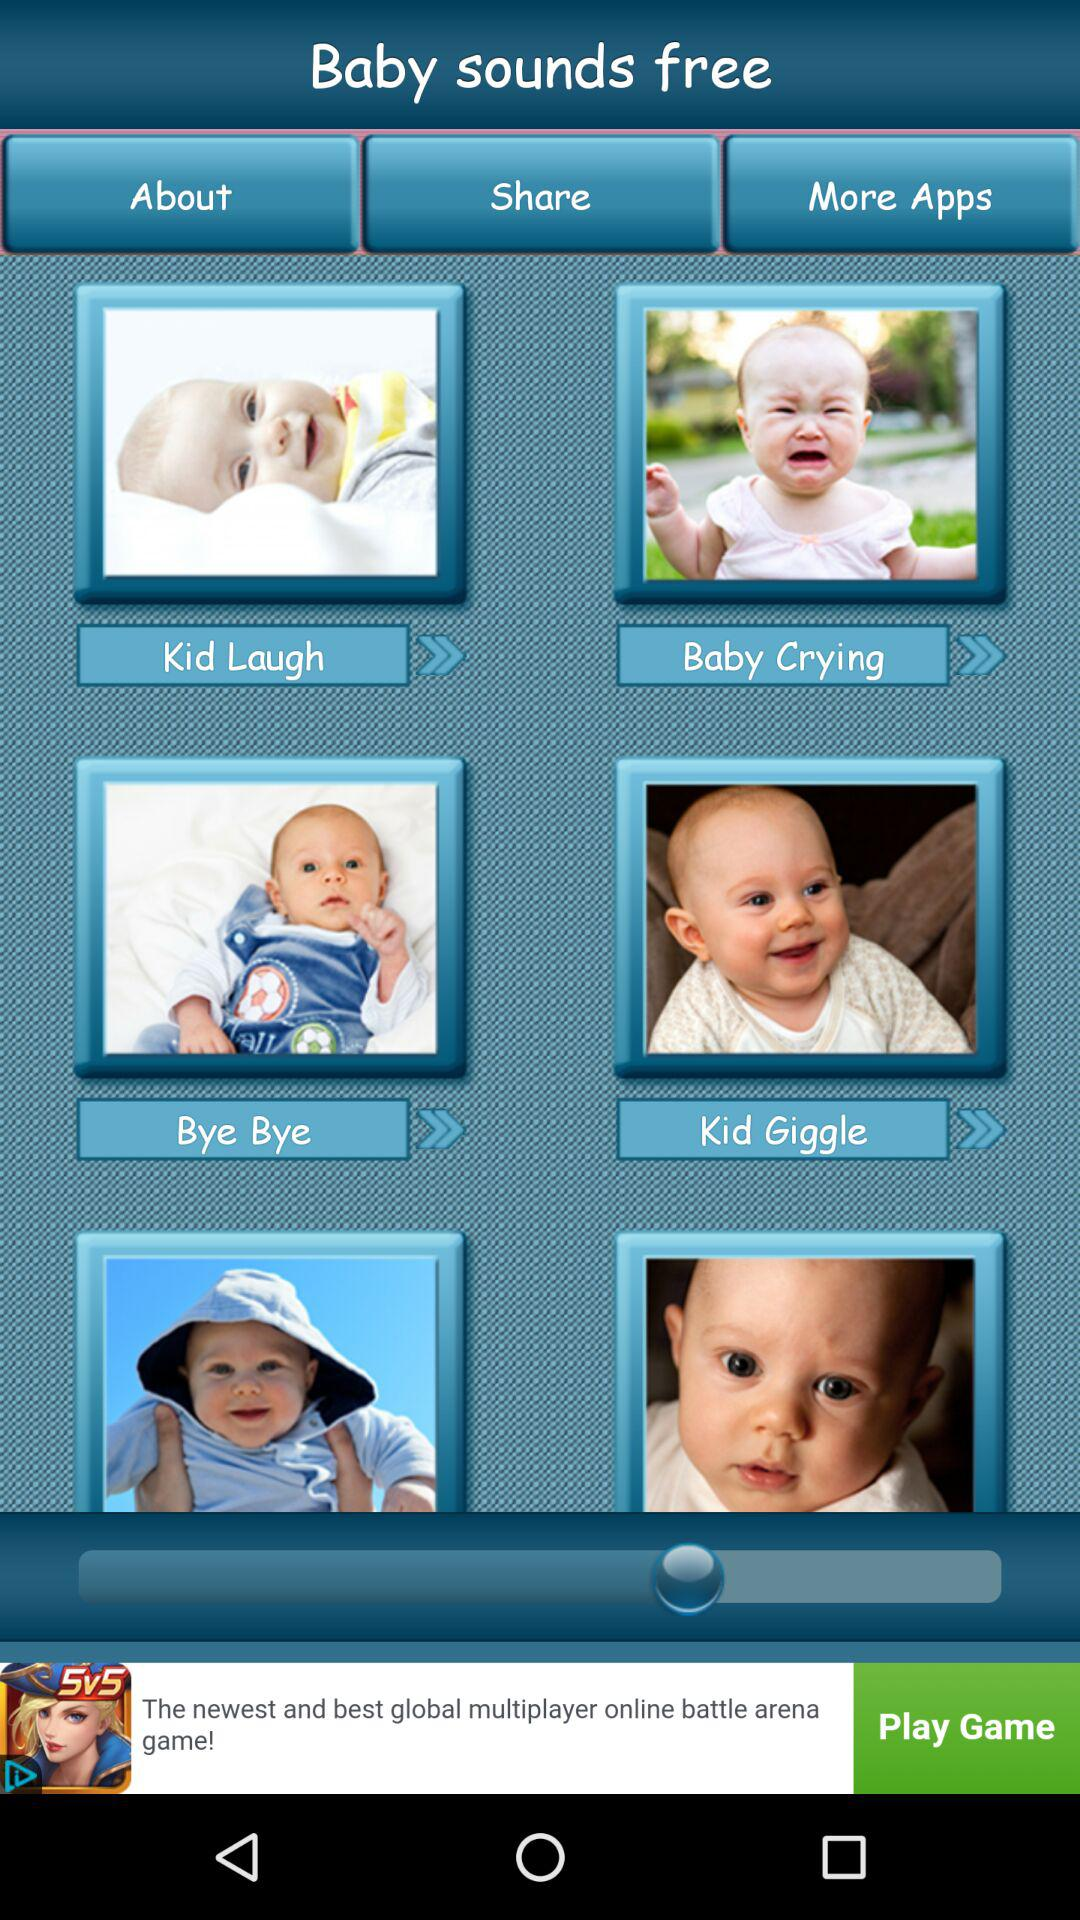What is the name of the application? The name of the application is "Baby sounds". 